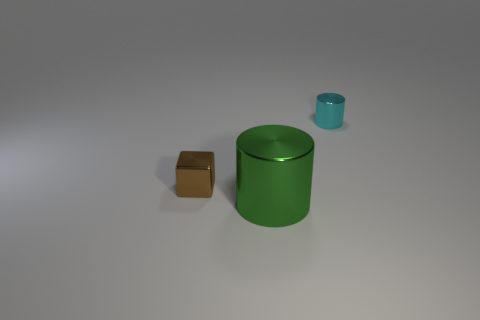Add 3 tiny cyan cylinders. How many objects exist? 6 Subtract all blocks. How many objects are left? 2 Subtract 0 purple cylinders. How many objects are left? 3 Subtract all large objects. Subtract all big metal blocks. How many objects are left? 2 Add 2 tiny cyan cylinders. How many tiny cyan cylinders are left? 3 Add 3 tiny blue metallic cubes. How many tiny blue metallic cubes exist? 3 